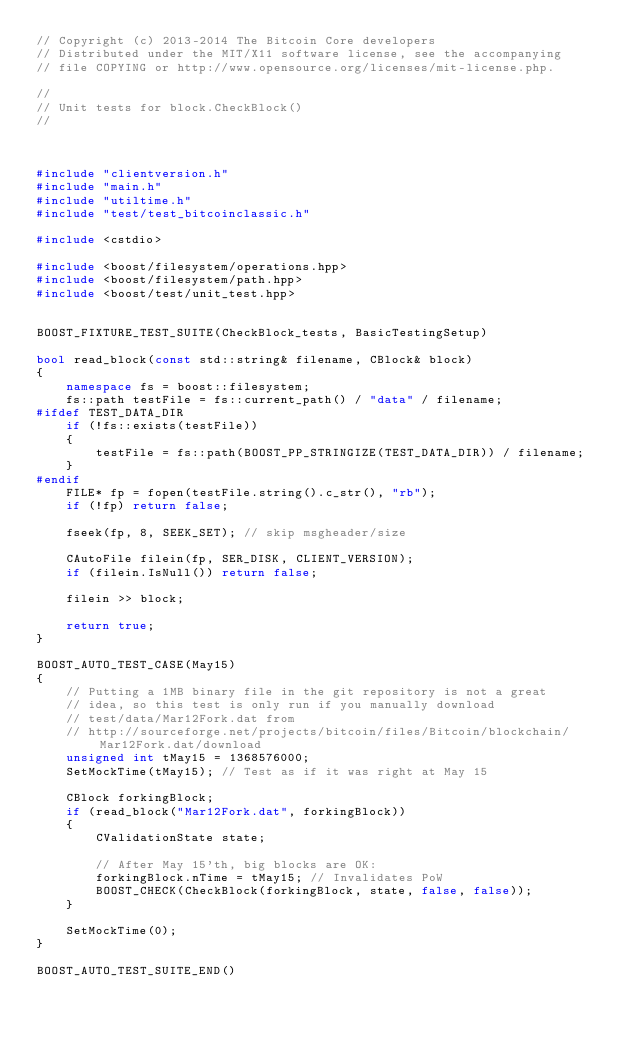Convert code to text. <code><loc_0><loc_0><loc_500><loc_500><_C++_>// Copyright (c) 2013-2014 The Bitcoin Core developers
// Distributed under the MIT/X11 software license, see the accompanying
// file COPYING or http://www.opensource.org/licenses/mit-license.php.

//
// Unit tests for block.CheckBlock()
//



#include "clientversion.h"
#include "main.h"
#include "utiltime.h"
#include "test/test_bitcoinclassic.h"

#include <cstdio>

#include <boost/filesystem/operations.hpp>
#include <boost/filesystem/path.hpp>
#include <boost/test/unit_test.hpp>


BOOST_FIXTURE_TEST_SUITE(CheckBlock_tests, BasicTestingSetup)

bool read_block(const std::string& filename, CBlock& block)
{
    namespace fs = boost::filesystem;
    fs::path testFile = fs::current_path() / "data" / filename;
#ifdef TEST_DATA_DIR
    if (!fs::exists(testFile))
    {
        testFile = fs::path(BOOST_PP_STRINGIZE(TEST_DATA_DIR)) / filename;
    }
#endif
    FILE* fp = fopen(testFile.string().c_str(), "rb");
    if (!fp) return false;

    fseek(fp, 8, SEEK_SET); // skip msgheader/size

    CAutoFile filein(fp, SER_DISK, CLIENT_VERSION);
    if (filein.IsNull()) return false;

    filein >> block;

    return true;
}

BOOST_AUTO_TEST_CASE(May15)
{
    // Putting a 1MB binary file in the git repository is not a great
    // idea, so this test is only run if you manually download
    // test/data/Mar12Fork.dat from
    // http://sourceforge.net/projects/bitcoin/files/Bitcoin/blockchain/Mar12Fork.dat/download
    unsigned int tMay15 = 1368576000;
    SetMockTime(tMay15); // Test as if it was right at May 15

    CBlock forkingBlock;
    if (read_block("Mar12Fork.dat", forkingBlock))
    {
        CValidationState state;

        // After May 15'th, big blocks are OK:
        forkingBlock.nTime = tMay15; // Invalidates PoW
        BOOST_CHECK(CheckBlock(forkingBlock, state, false, false));
    }

    SetMockTime(0);
}

BOOST_AUTO_TEST_SUITE_END()
</code> 